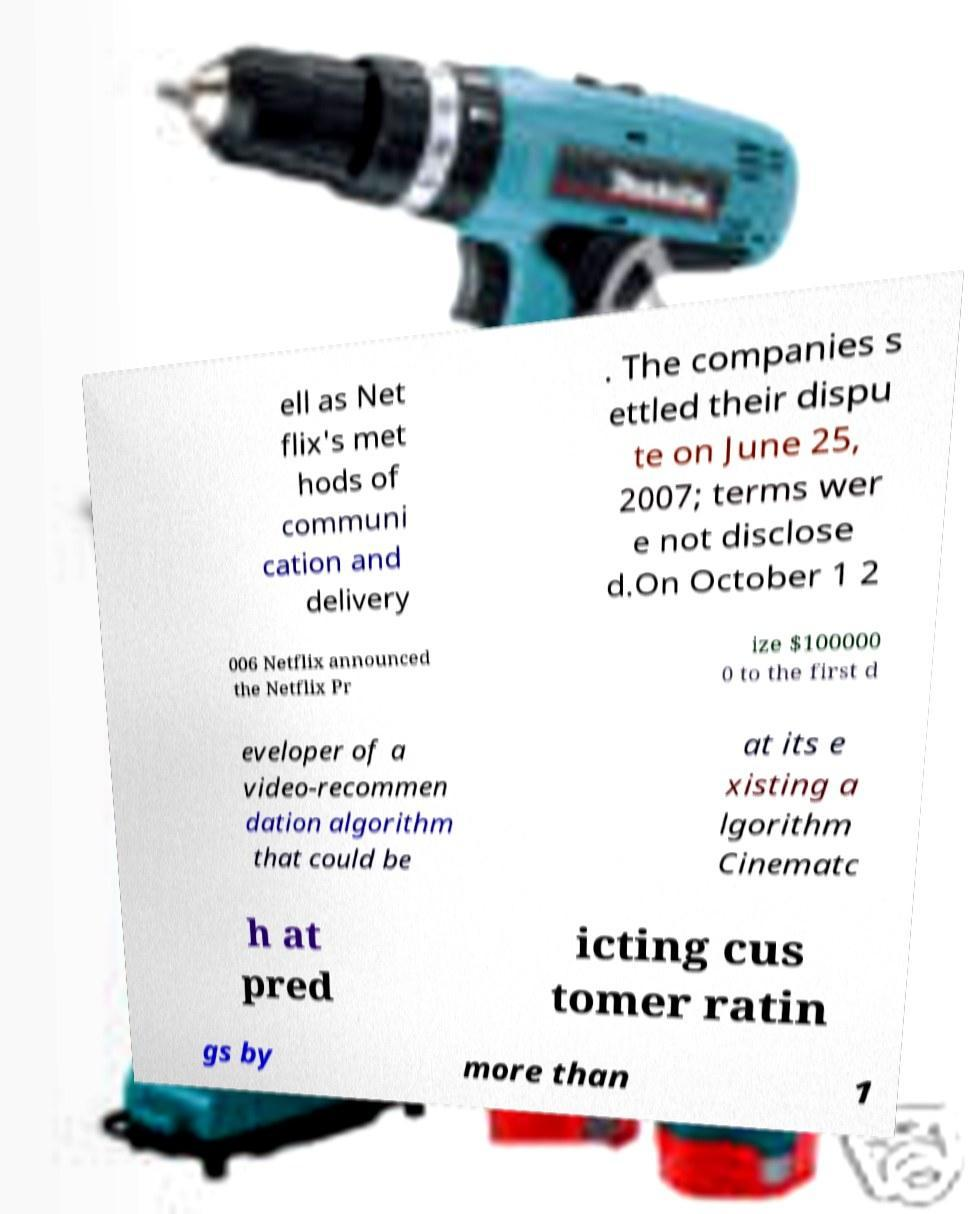I need the written content from this picture converted into text. Can you do that? ell as Net flix's met hods of communi cation and delivery . The companies s ettled their dispu te on June 25, 2007; terms wer e not disclose d.On October 1 2 006 Netflix announced the Netflix Pr ize $100000 0 to the first d eveloper of a video-recommen dation algorithm that could be at its e xisting a lgorithm Cinematc h at pred icting cus tomer ratin gs by more than 1 